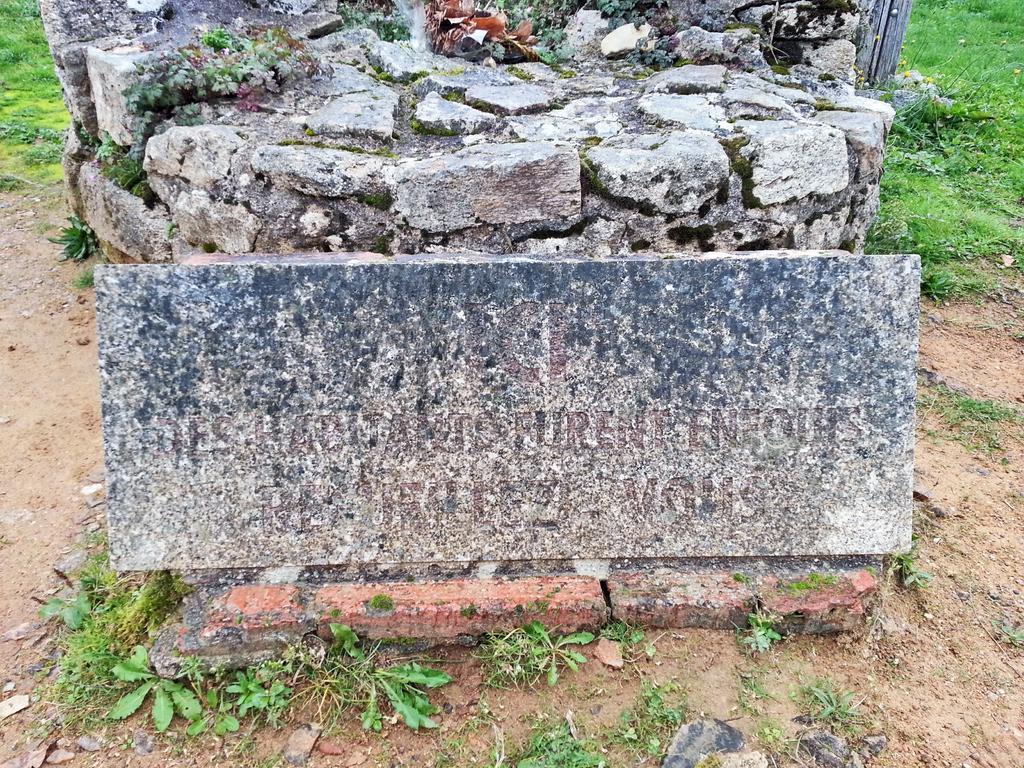In one or two sentences, can you explain what this image depicts? In this image, we can see a marble with some text. At the bottom and background we can see plants and grass. Here there is a stone wall. 